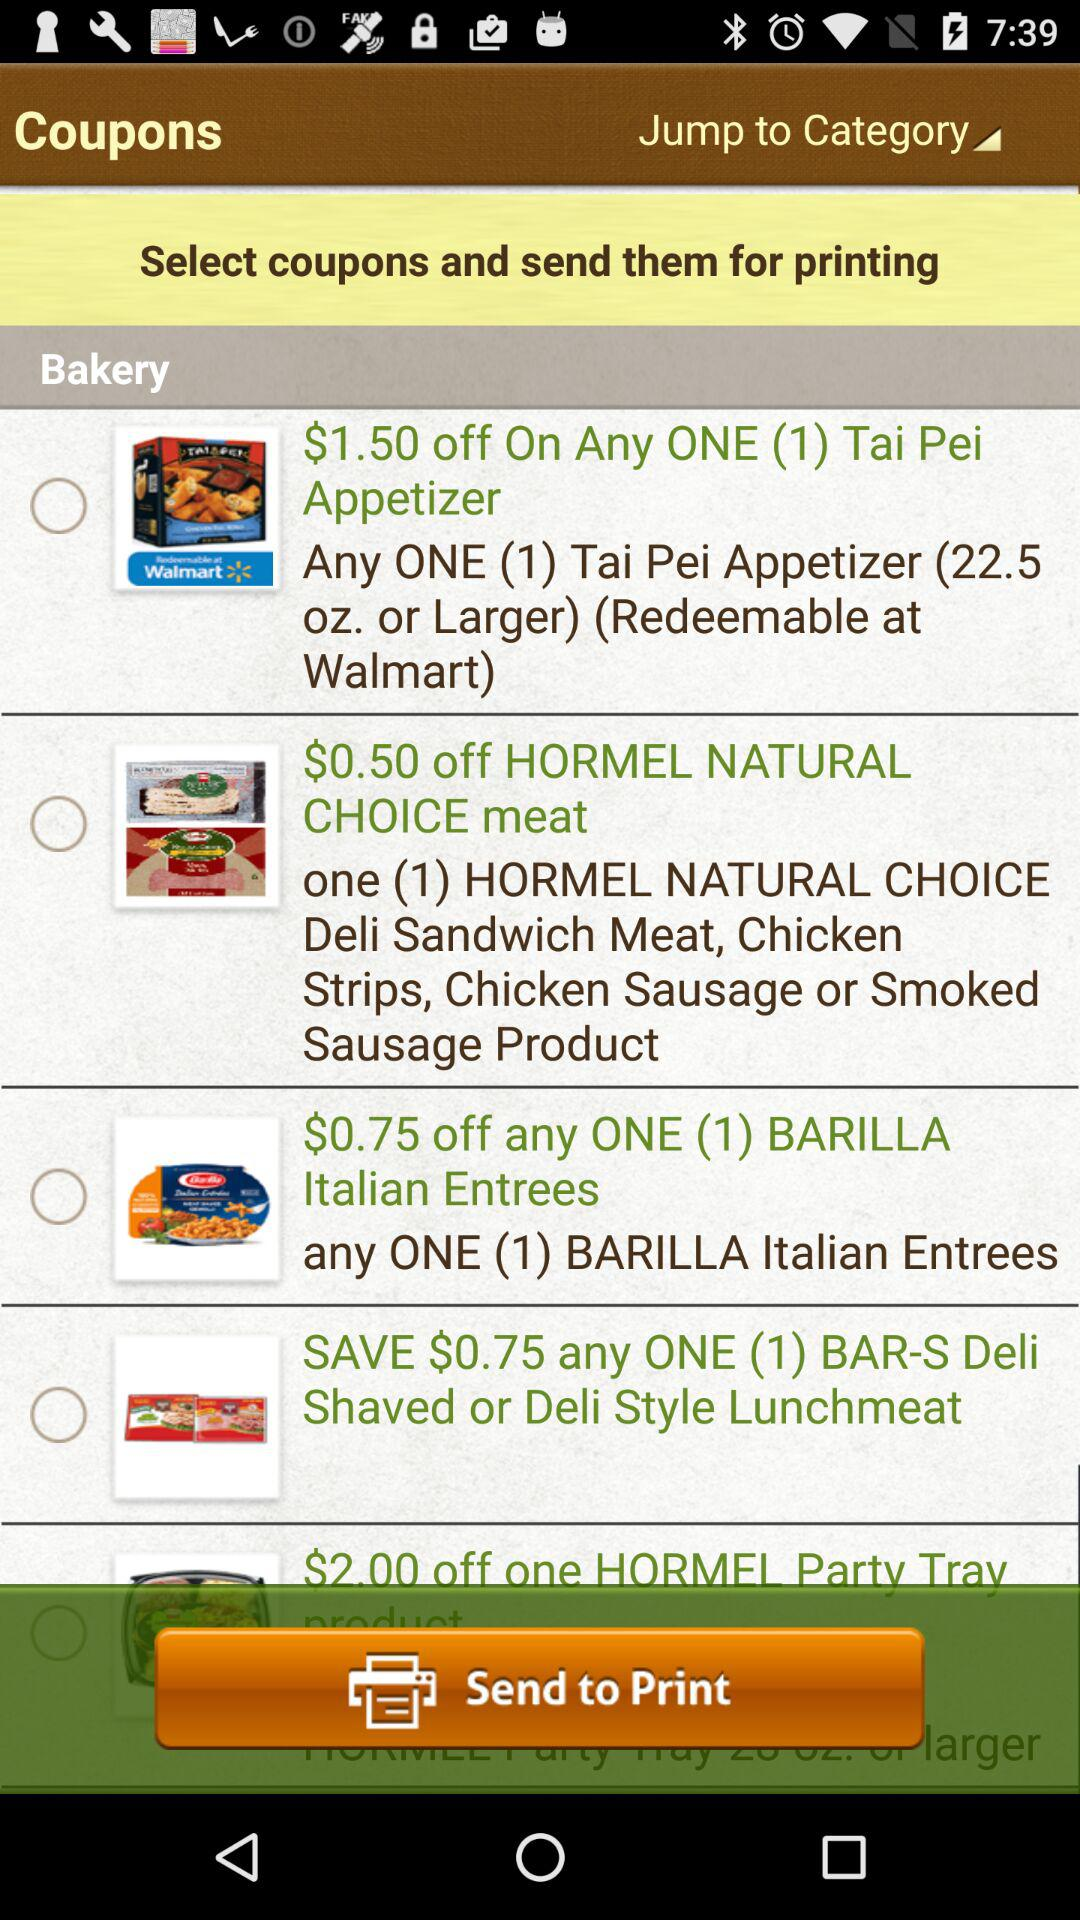How much of a discount is available on "HORMEL NATURAL CHOICE" meat? There is a $0.50 discount on "HORMEL NATURAL CHOICE" meat. 